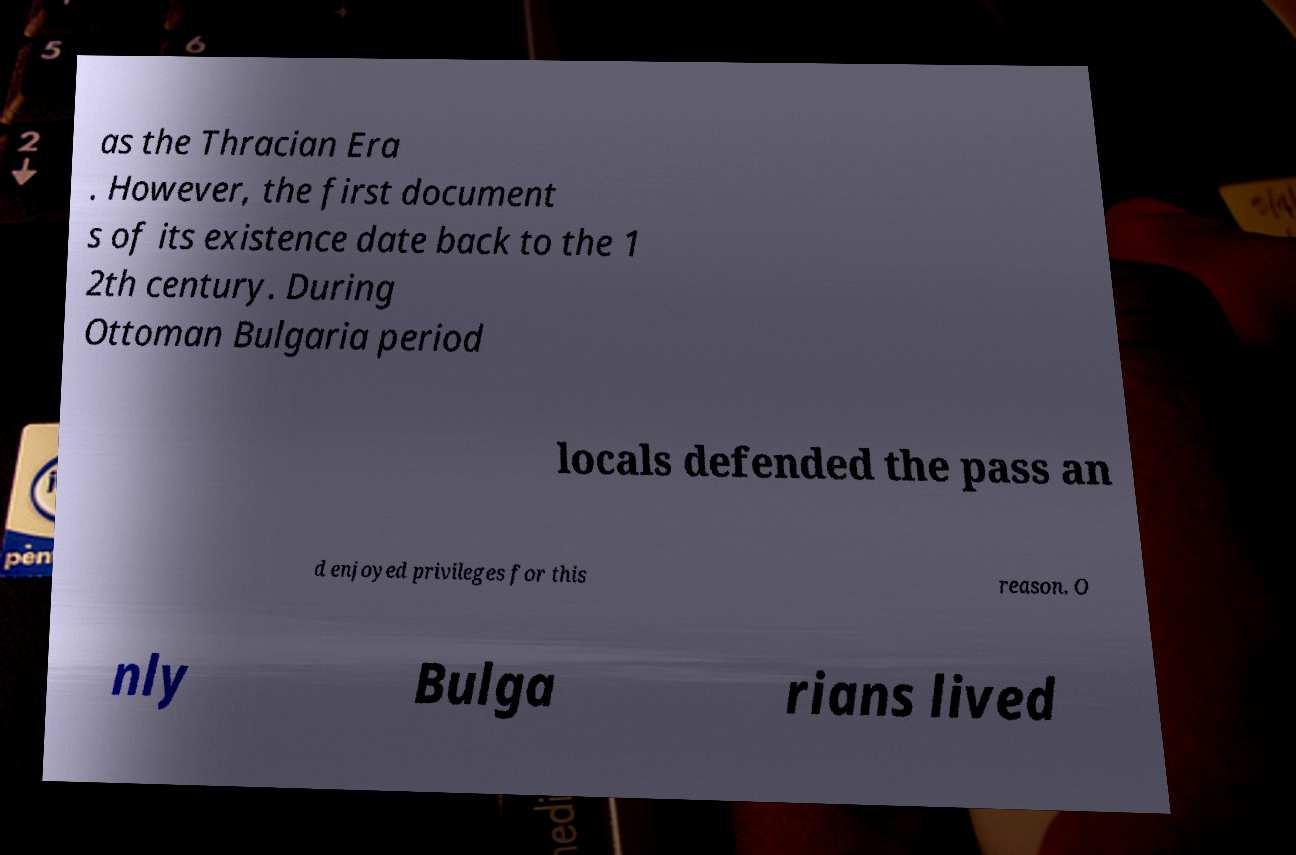What historical significance might the '12th century' have in the context of this image? The 12th century is significant as it marks a period in medieval history when the political landscape of the Balkans was changing. It was a time conducive to the establishment and documentation of varied settlements, including those in modern-day Bulgaria. This might indicate the period when the specific local privileges mentioned in the text started to be recognized officially. 